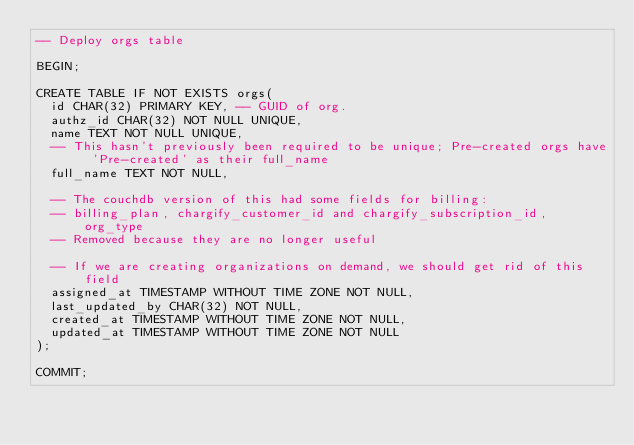<code> <loc_0><loc_0><loc_500><loc_500><_SQL_>-- Deploy orgs table

BEGIN;

CREATE TABLE IF NOT EXISTS orgs(
  id CHAR(32) PRIMARY KEY, -- GUID of org.
  authz_id CHAR(32) NOT NULL UNIQUE,
  name TEXT NOT NULL UNIQUE,
  -- This hasn't previously been required to be unique; Pre-created orgs have 'Pre-created' as their full_name
  full_name TEXT NOT NULL,

  -- The couchdb version of this had some fields for billing:
  -- billing_plan, chargify_customer_id and chargify_subscription_id, org_type
  -- Removed because they are no longer useful

  -- If we are creating organizations on demand, we should get rid of this field
  assigned_at TIMESTAMP WITHOUT TIME ZONE NOT NULL,
  last_updated_by CHAR(32) NOT NULL,
  created_at TIMESTAMP WITHOUT TIME ZONE NOT NULL,
  updated_at TIMESTAMP WITHOUT TIME ZONE NOT NULL
);

COMMIT;
</code> 